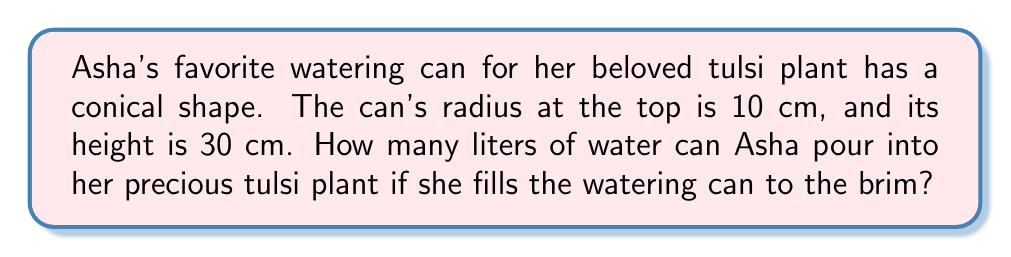Solve this math problem. Let's solve this step-by-step:

1) The volume of a cone can be found using the formula:

   $$V = \int_0^h \pi r(x)^2 dx$$

   where $h$ is the height and $r(x)$ is the radius at height $x$.

2) In a cone, the radius at any height $x$ is proportional to the distance from the top:

   $$\frac{r(x)}{R} = \frac{x}{h}$$

   where $R$ is the radius at the base and $h$ is the height.

3) Solving for $r(x)$:

   $$r(x) = \frac{Rx}{h}$$

4) In our case, $R = 10$ cm and $h = 30$ cm. Substituting:

   $$r(x) = \frac{10x}{30} = \frac{x}{3}$$

5) Now, let's set up our integral:

   $$V = \int_0^{30} \pi (\frac{x}{3})^2 dx$$

6) Simplify inside the integral:

   $$V = \frac{\pi}{9} \int_0^{30} x^2 dx$$

7) Integrate:

   $$V = \frac{\pi}{9} [\frac{x^3}{3}]_0^{30}$$

8) Evaluate the bounds:

   $$V = \frac{\pi}{9} (\frac{30^3}{3} - 0) = \frac{\pi}{9} \cdot \frac{27000}{3} = 1000\pi$$

9) This gives us the volume in cubic centimeters. To convert to liters:

   $$V = 1000\pi \cdot \frac{1}{1000} = \pi \text{ liters}$$

10) $\pi$ is approximately 3.14159 liters.
Answer: $\pi$ liters (approximately 3.14 liters) 